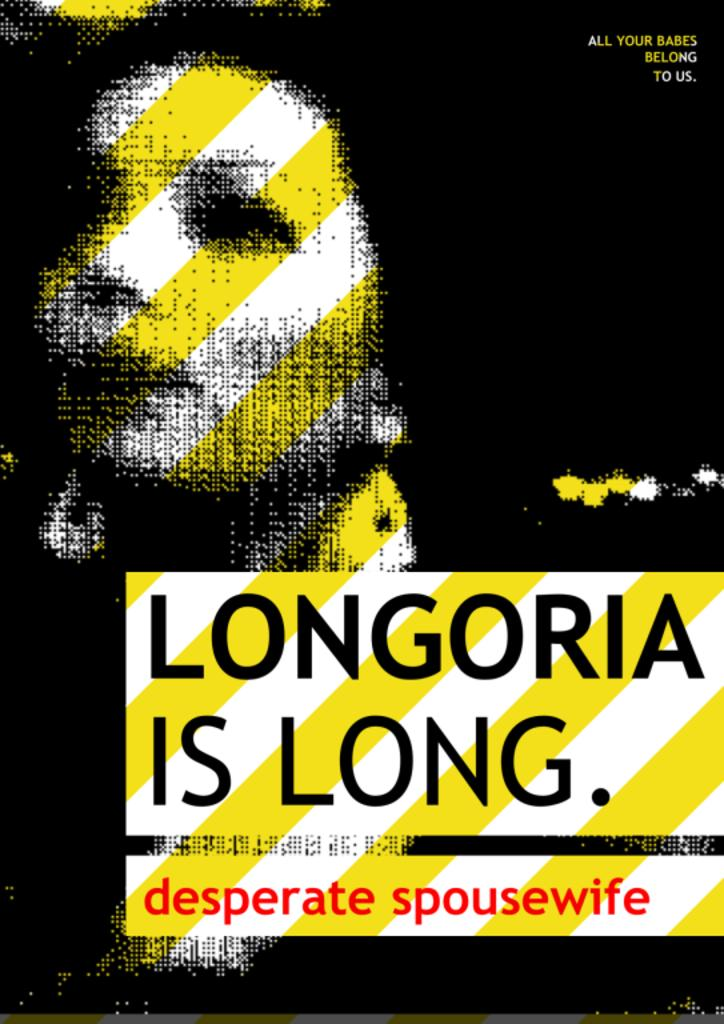<image>
Summarize the visual content of the image. A sign that says Longoria is Long, desperate spousewife. 